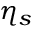<formula> <loc_0><loc_0><loc_500><loc_500>\eta _ { s }</formula> 